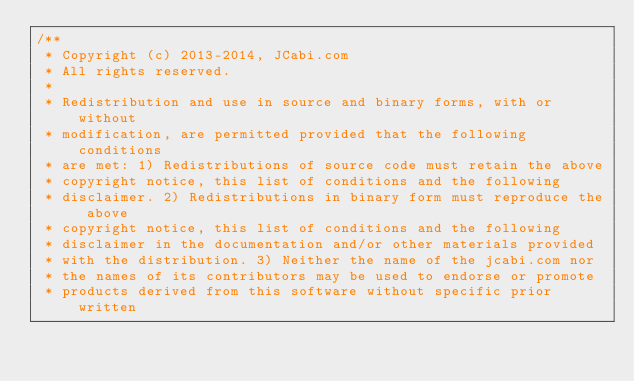Convert code to text. <code><loc_0><loc_0><loc_500><loc_500><_Java_>/**
 * Copyright (c) 2013-2014, JCabi.com
 * All rights reserved.
 *
 * Redistribution and use in source and binary forms, with or without
 * modification, are permitted provided that the following conditions
 * are met: 1) Redistributions of source code must retain the above
 * copyright notice, this list of conditions and the following
 * disclaimer. 2) Redistributions in binary form must reproduce the above
 * copyright notice, this list of conditions and the following
 * disclaimer in the documentation and/or other materials provided
 * with the distribution. 3) Neither the name of the jcabi.com nor
 * the names of its contributors may be used to endorse or promote
 * products derived from this software without specific prior written</code> 